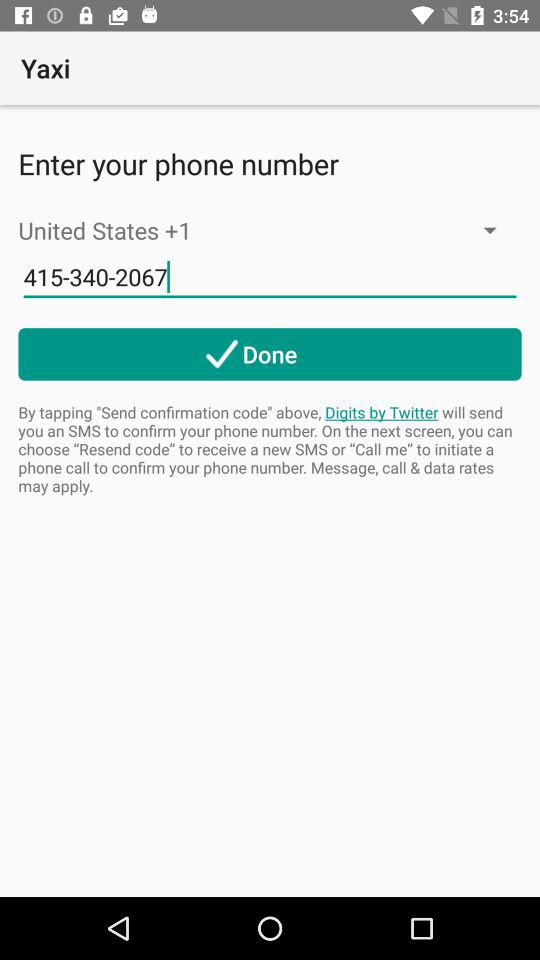Which country code is showing? The shown country code is +1. 